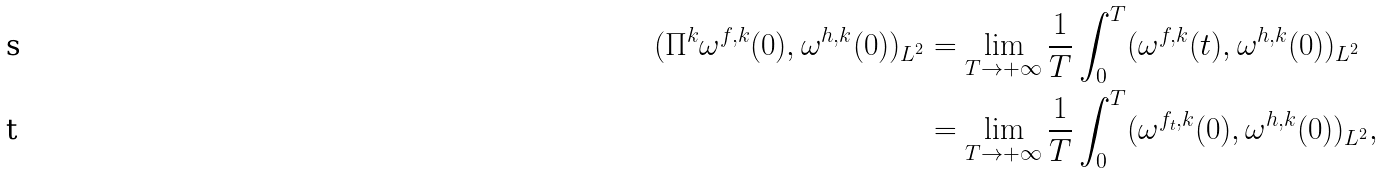Convert formula to latex. <formula><loc_0><loc_0><loc_500><loc_500>( \Pi ^ { k } \omega ^ { f , k } ( 0 ) , \omega ^ { h , k } ( 0 ) ) _ { L ^ { 2 } } & = \lim _ { T \to + \infty } \frac { 1 } { T } \int _ { 0 } ^ { T } ( \omega ^ { f , k } ( t ) , \omega ^ { h , k } ( 0 ) ) _ { L ^ { 2 } } \\ & = \lim _ { T \to + \infty } \frac { 1 } { T } \int _ { 0 } ^ { T } ( \omega ^ { f _ { t } , k } ( 0 ) , \omega ^ { h , k } ( 0 ) ) _ { L ^ { 2 } } ,</formula> 